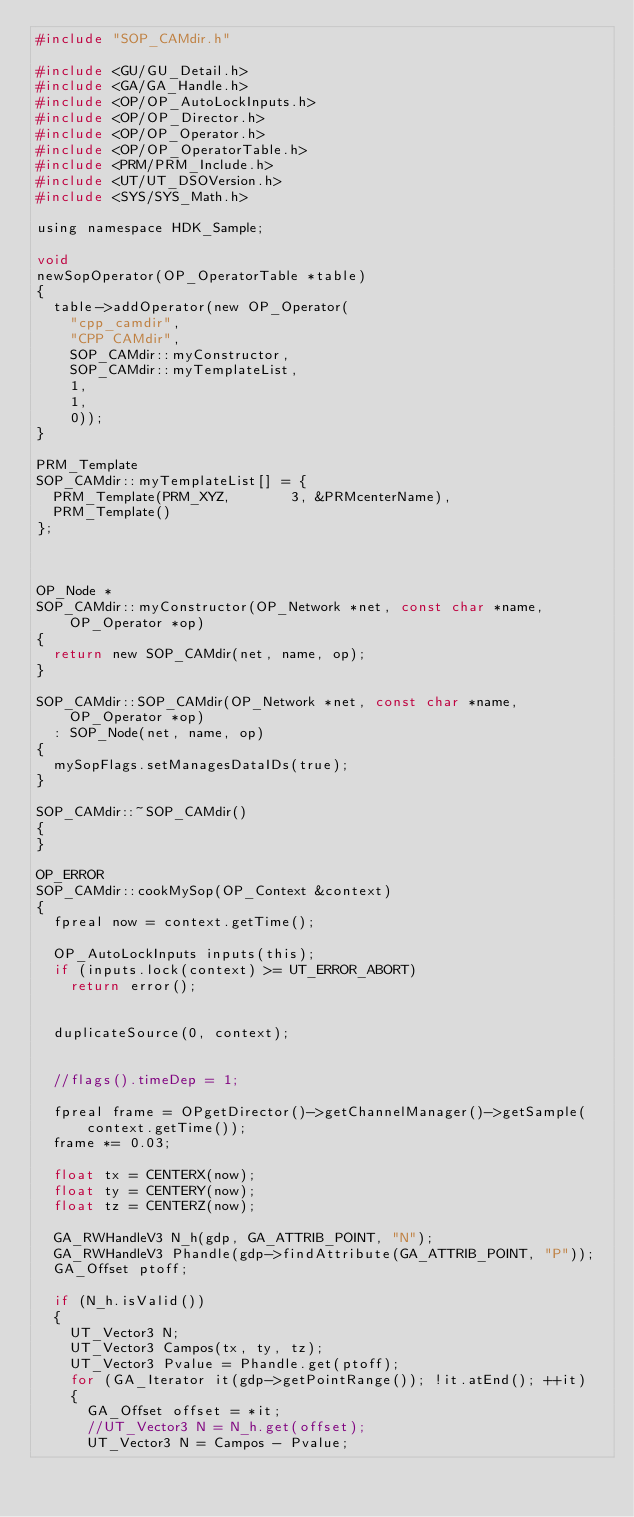<code> <loc_0><loc_0><loc_500><loc_500><_C_>#include "SOP_CAMdir.h"

#include <GU/GU_Detail.h>
#include <GA/GA_Handle.h>
#include <OP/OP_AutoLockInputs.h>
#include <OP/OP_Director.h>
#include <OP/OP_Operator.h>
#include <OP/OP_OperatorTable.h>
#include <PRM/PRM_Include.h>
#include <UT/UT_DSOVersion.h>
#include <SYS/SYS_Math.h>

using namespace HDK_Sample;

void
newSopOperator(OP_OperatorTable *table)
{
	table->addOperator(new OP_Operator(
		"cpp_camdir",
		"CPP CAMdir",
		SOP_CAMdir::myConstructor,
		SOP_CAMdir::myTemplateList,
		1,
		1,
		0));
}

PRM_Template
SOP_CAMdir::myTemplateList[] = {
	PRM_Template(PRM_XYZ,       3, &PRMcenterName),
	PRM_Template()
};



OP_Node *
SOP_CAMdir::myConstructor(OP_Network *net, const char *name, OP_Operator *op)
{
	return new SOP_CAMdir(net, name, op);
}

SOP_CAMdir::SOP_CAMdir(OP_Network *net, const char *name, OP_Operator *op)
	: SOP_Node(net, name, op)
{
	mySopFlags.setManagesDataIDs(true);
}

SOP_CAMdir::~SOP_CAMdir()
{
}

OP_ERROR
SOP_CAMdir::cookMySop(OP_Context &context)
{
	fpreal now = context.getTime();

	OP_AutoLockInputs inputs(this);
	if (inputs.lock(context) >= UT_ERROR_ABORT)
		return error();


	duplicateSource(0, context);


	//flags().timeDep = 1;

	fpreal frame = OPgetDirector()->getChannelManager()->getSample(context.getTime());
	frame *= 0.03;

	float tx = CENTERX(now);
	float ty = CENTERY(now);
	float tz = CENTERZ(now);

	GA_RWHandleV3 N_h(gdp, GA_ATTRIB_POINT, "N");
	GA_RWHandleV3 Phandle(gdp->findAttribute(GA_ATTRIB_POINT, "P"));
	GA_Offset ptoff;

	if (N_h.isValid())
	{
		UT_Vector3 N;
		UT_Vector3 Campos(tx, ty, tz);
		UT_Vector3 Pvalue = Phandle.get(ptoff);
		for (GA_Iterator it(gdp->getPointRange()); !it.atEnd(); ++it)
		{
			GA_Offset offset = *it;
			//UT_Vector3 N = N_h.get(offset);
			UT_Vector3 N = Campos - Pvalue;</code> 